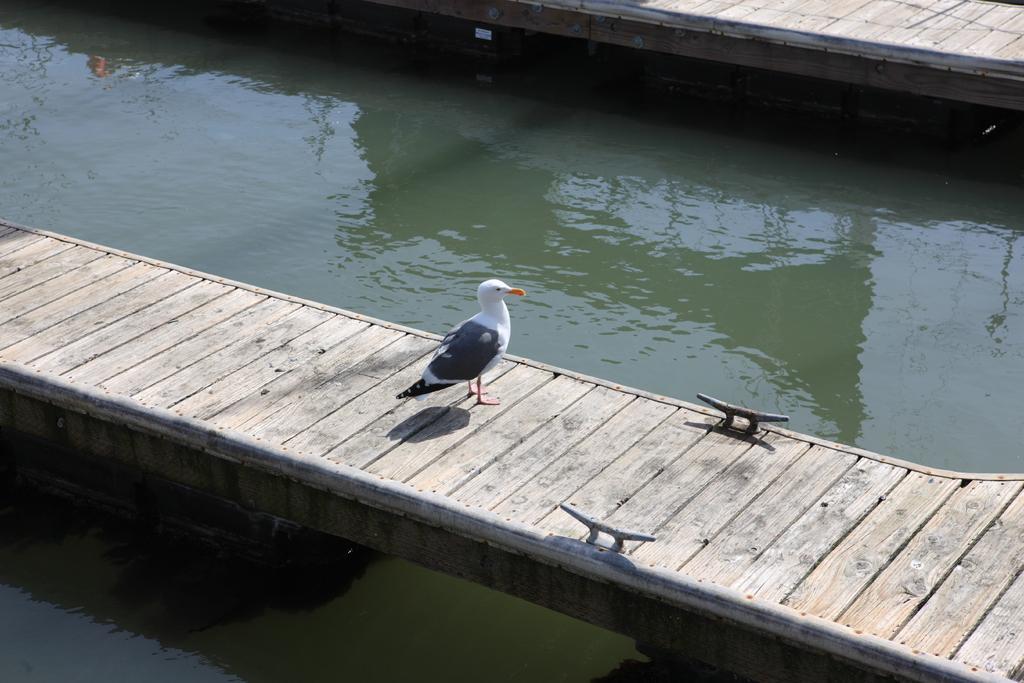Could you give a brief overview of what you see in this image? In this image I can see a wooden platform in the centre and both side of it I can see water. I can also see a bird is standing on it and I can see colour of this bird is white and black. On the top of this image I can see one more platform. 